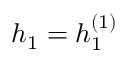Convert formula to latex. <formula><loc_0><loc_0><loc_500><loc_500>h _ { 1 } = h _ { 1 } ^ { ( 1 ) }</formula> 